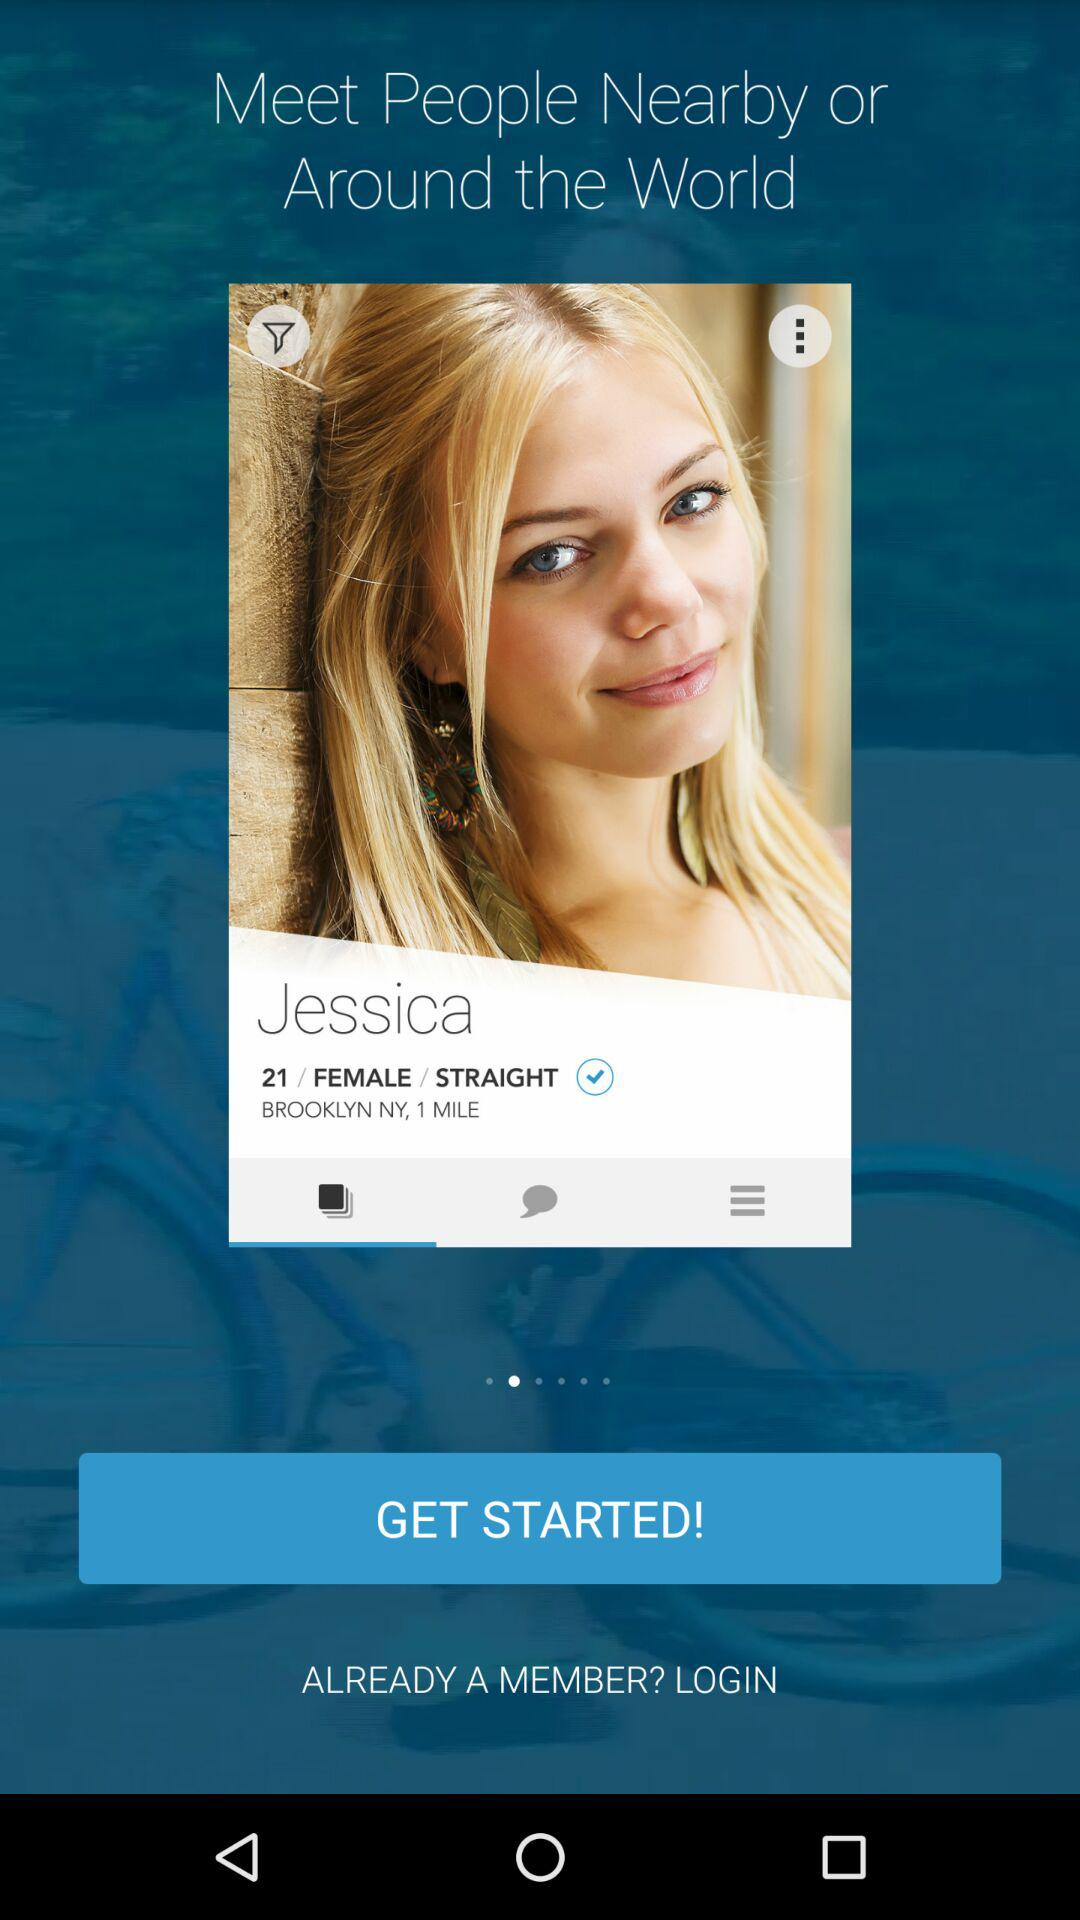What is the user name? The user name is Jessica. 